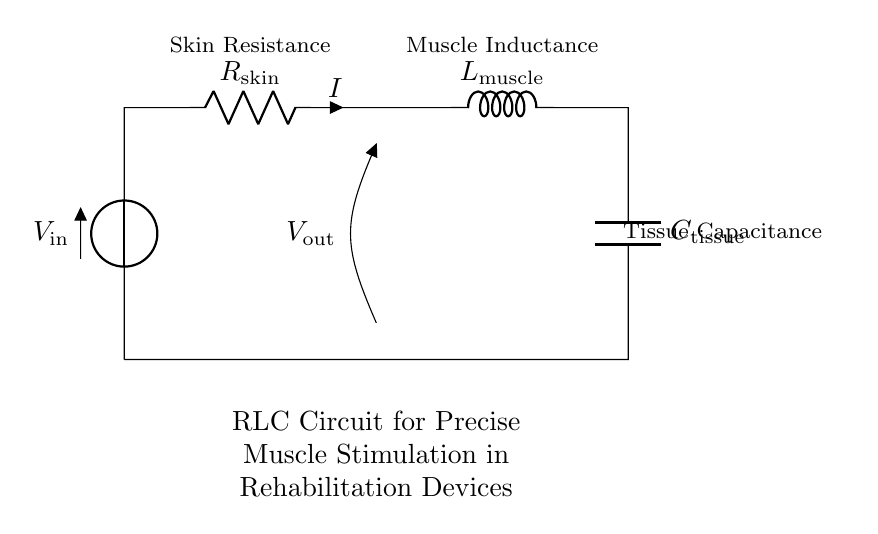What is the input voltage of this circuit? The input voltage is denoted as V_in in the diagram, which is shown at the top of the circuit.
Answer: V_in What component represents the resistance of the skin? The skin resistance is represented by R_skin, labeled in the circuit diagram.
Answer: R_skin What does L represent in this circuit? L is labeled as the inductance of the muscle, indicating the muscle's property to store energy in a magnetic field.
Answer: L_muscle How many components are in this RLC circuit? The circuit contains three main components: a resistor, an inductor, and a capacitor, along with the voltage source.
Answer: Three What is the electrical characteristic of the tissue represented by? The capacitance of the tissue is represented by C, labeled as C_tissue in the circuit diagram, reflecting its ability to store electrical energy.
Answer: C_tissue If the skin resistance increases, how will it affect the current? An increase in skin resistance would result in a decrease in current, as per Ohm's law (I = V/R), where current is inversely proportional to resistance.
Answer: Decrease What type of circuit is this exemplifying? This RLC circuit illustrates a series connection of resistor, inductor, and capacitor specifically adapted for muscle stimulation applications in rehabilitation devices.
Answer: RLC circuit 